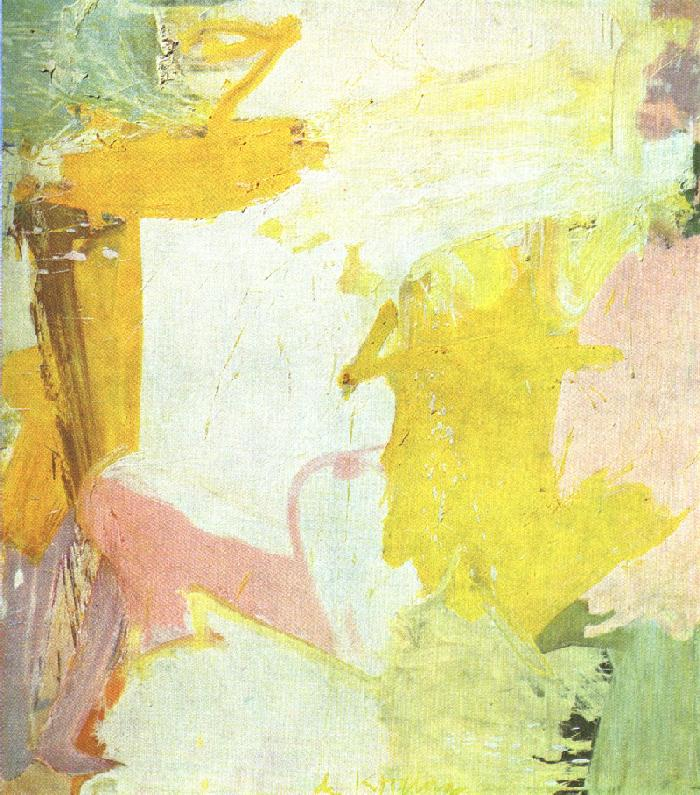What emotions might this painting evoke? The blend of soft pastel colors and dynamic brushstrokes could evoke feelings of tranquility and warmth. The light yellow tones may suggest cheerfulness or optimism, while the pink hues could invoke a sense of calm or affection. The freedom of the abstract form allows viewers to experience a personal and perhaps introspective journey with the painting. 